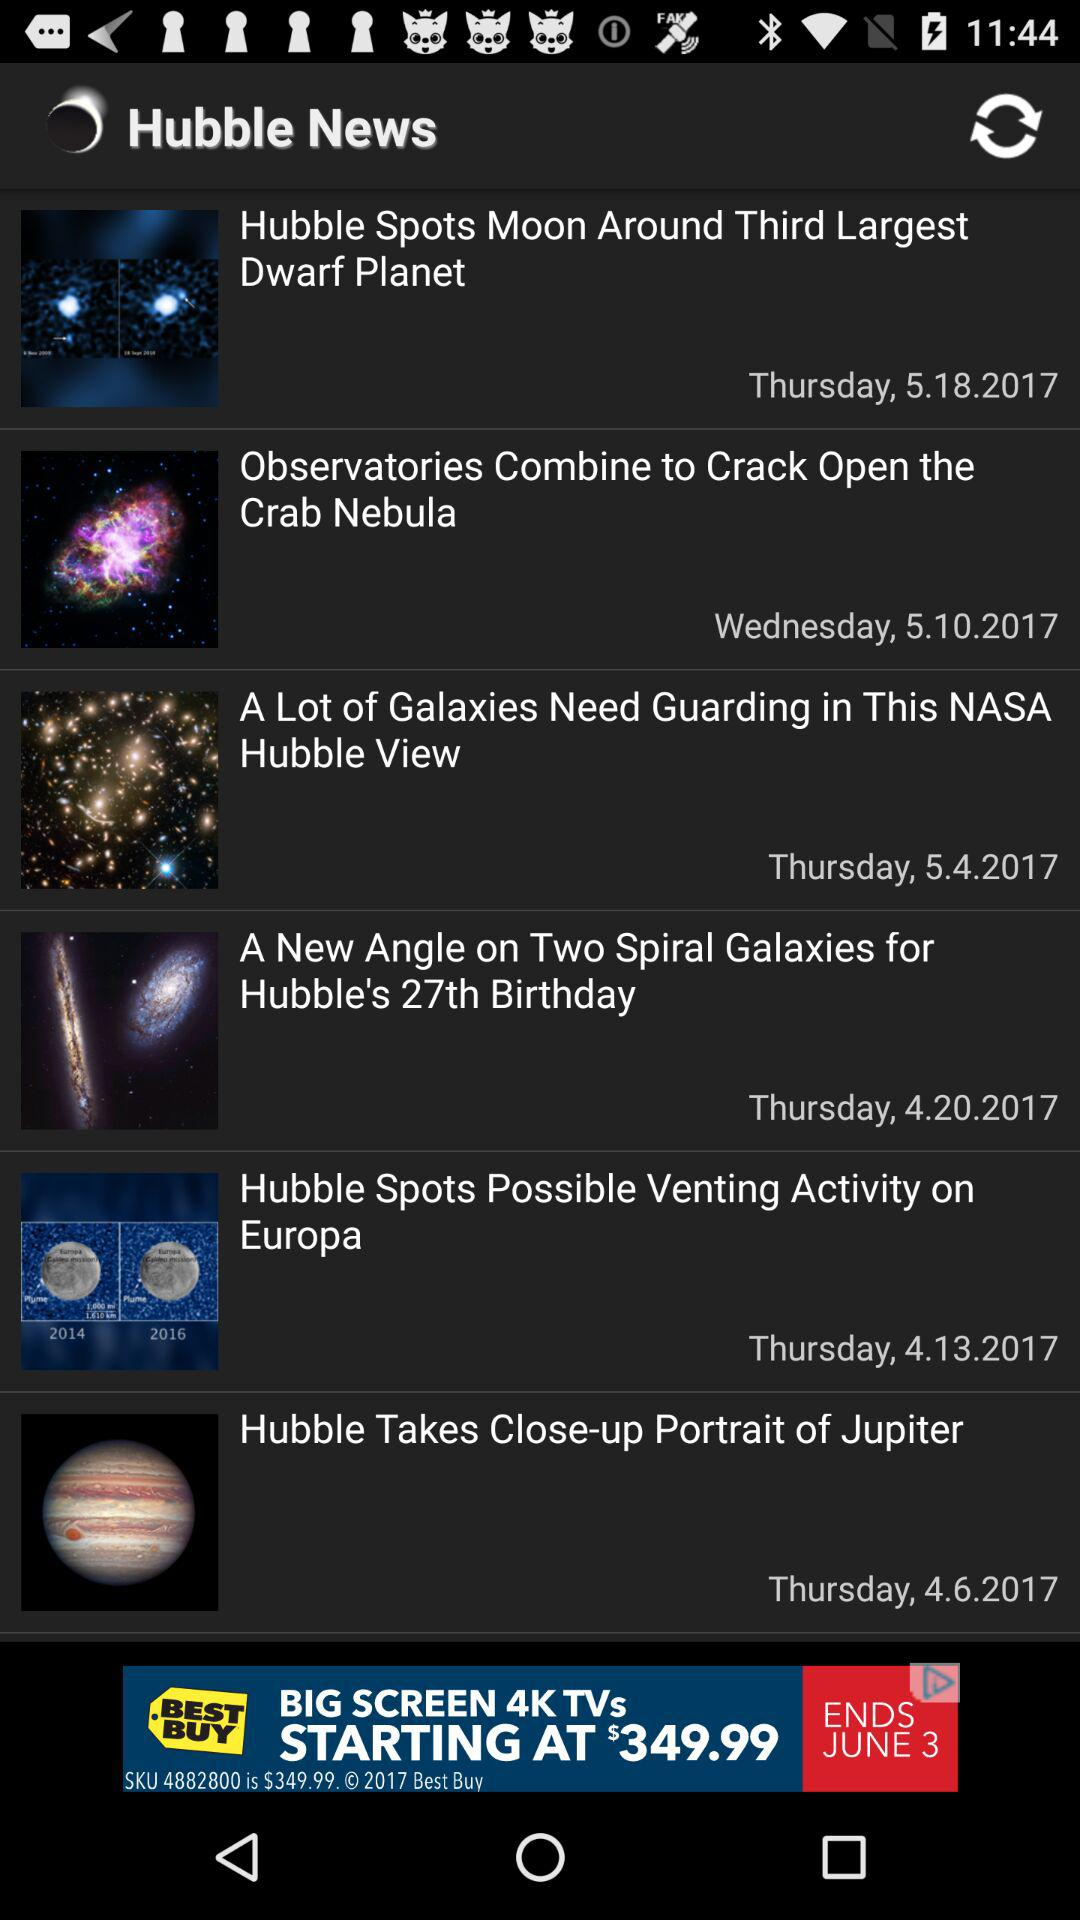What is the name of the application? The name of the application is "Hubble Space Center". 